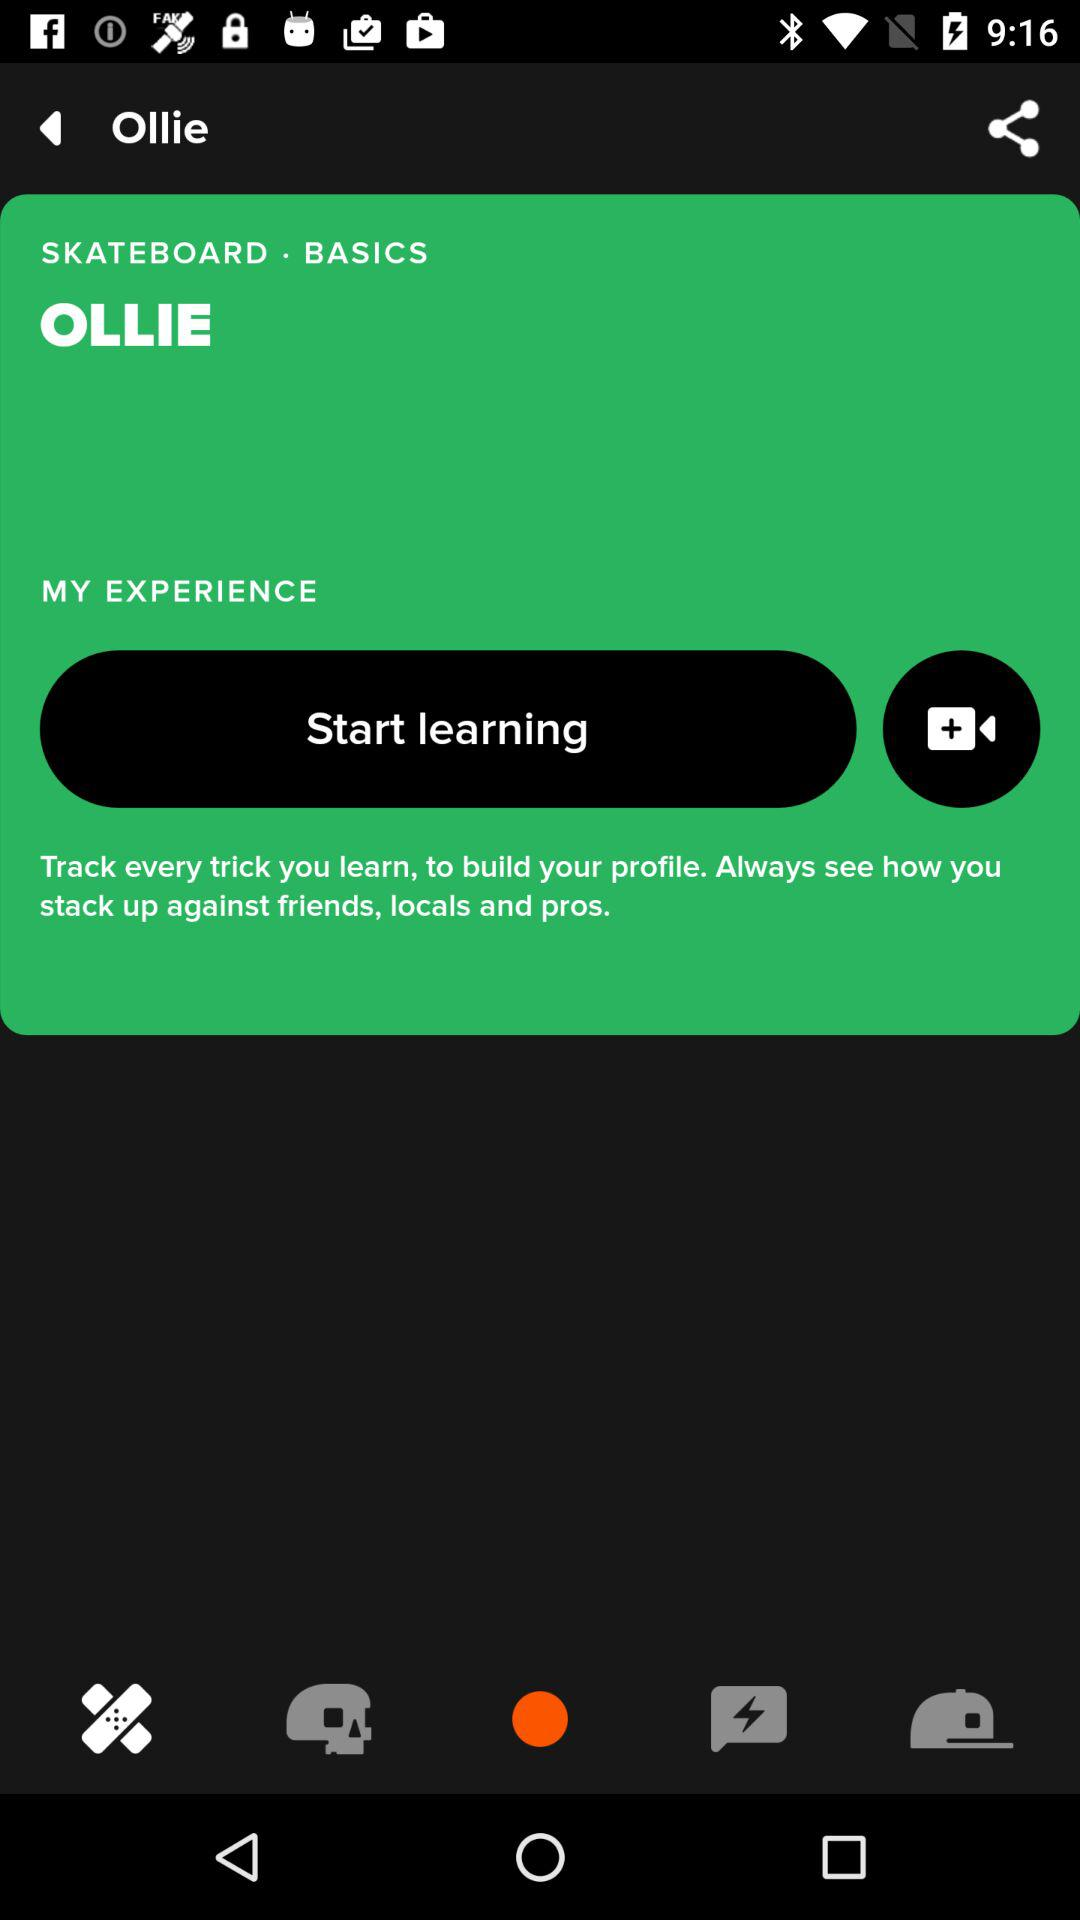Which company is the application powered by?
When the provided information is insufficient, respond with <no answer>. <no answer> 